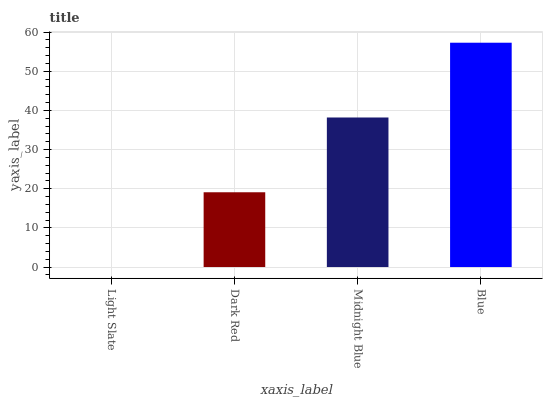Is Light Slate the minimum?
Answer yes or no. Yes. Is Blue the maximum?
Answer yes or no. Yes. Is Dark Red the minimum?
Answer yes or no. No. Is Dark Red the maximum?
Answer yes or no. No. Is Dark Red greater than Light Slate?
Answer yes or no. Yes. Is Light Slate less than Dark Red?
Answer yes or no. Yes. Is Light Slate greater than Dark Red?
Answer yes or no. No. Is Dark Red less than Light Slate?
Answer yes or no. No. Is Midnight Blue the high median?
Answer yes or no. Yes. Is Dark Red the low median?
Answer yes or no. Yes. Is Blue the high median?
Answer yes or no. No. Is Light Slate the low median?
Answer yes or no. No. 